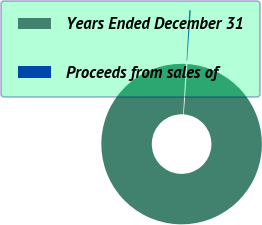Convert chart to OTSL. <chart><loc_0><loc_0><loc_500><loc_500><pie_chart><fcel>Years Ended December 31<fcel>Proceeds from sales of<nl><fcel>99.7%<fcel>0.3%<nl></chart> 